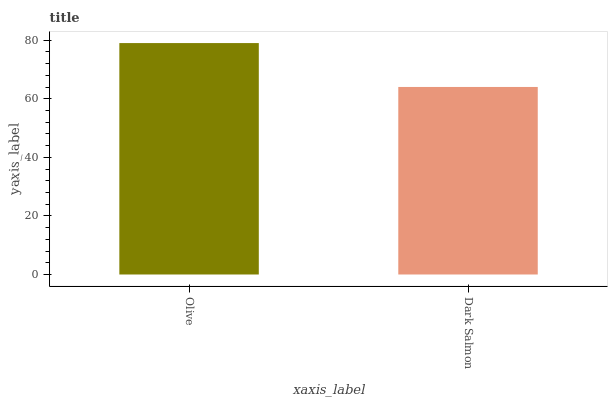Is Dark Salmon the minimum?
Answer yes or no. Yes. Is Olive the maximum?
Answer yes or no. Yes. Is Dark Salmon the maximum?
Answer yes or no. No. Is Olive greater than Dark Salmon?
Answer yes or no. Yes. Is Dark Salmon less than Olive?
Answer yes or no. Yes. Is Dark Salmon greater than Olive?
Answer yes or no. No. Is Olive less than Dark Salmon?
Answer yes or no. No. Is Olive the high median?
Answer yes or no. Yes. Is Dark Salmon the low median?
Answer yes or no. Yes. Is Dark Salmon the high median?
Answer yes or no. No. Is Olive the low median?
Answer yes or no. No. 